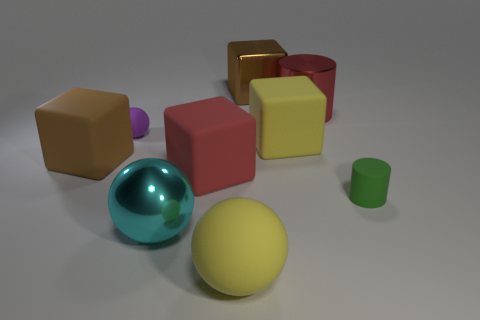What material is the yellow ball that is the same size as the yellow matte cube?
Make the answer very short. Rubber. What is the shape of the rubber object that is on the right side of the big brown matte thing and left of the cyan ball?
Your response must be concise. Sphere. Is the size of the yellow thing that is behind the tiny cylinder the same as the green rubber cylinder in front of the purple thing?
Provide a succinct answer. No. What is the shape of the large metallic thing on the right side of the big brown shiny block behind the small green thing?
Give a very brief answer. Cylinder. Is the color of the large rubber object that is to the left of the red matte object the same as the shiny cube?
Make the answer very short. Yes. There is a object that is both on the right side of the metallic cube and behind the purple matte ball; what color is it?
Your answer should be very brief. Red. Is there a yellow cube made of the same material as the green cylinder?
Give a very brief answer. Yes. What size is the purple rubber thing?
Offer a terse response. Small. What is the size of the red object behind the yellow matte thing behind the brown matte object?
Give a very brief answer. Large. There is another thing that is the same shape as the tiny green object; what is it made of?
Provide a short and direct response. Metal. 